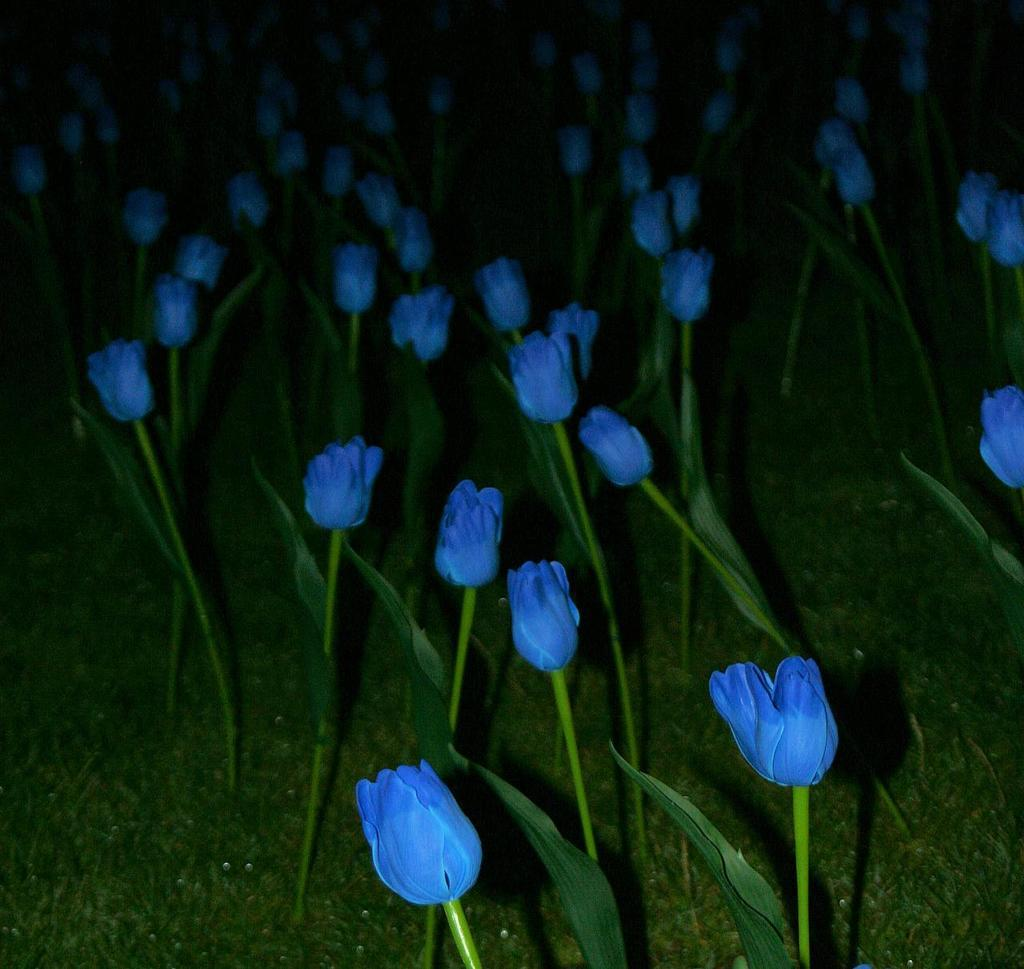What time of day is the image taken? The image is taken at night. What type of plants and flowers are visible on the ground? There are tulip plants and flowers on the ground. What color are the tulips? The tulips are blue in color. How many marbles are scattered around the tulips in the image? There are no marbles present in the image; it only features tulip plants and flowers. What color are the bikes parked near the tulips in the image? There are no bikes present in the image; it only features tulip plants and flowers. 